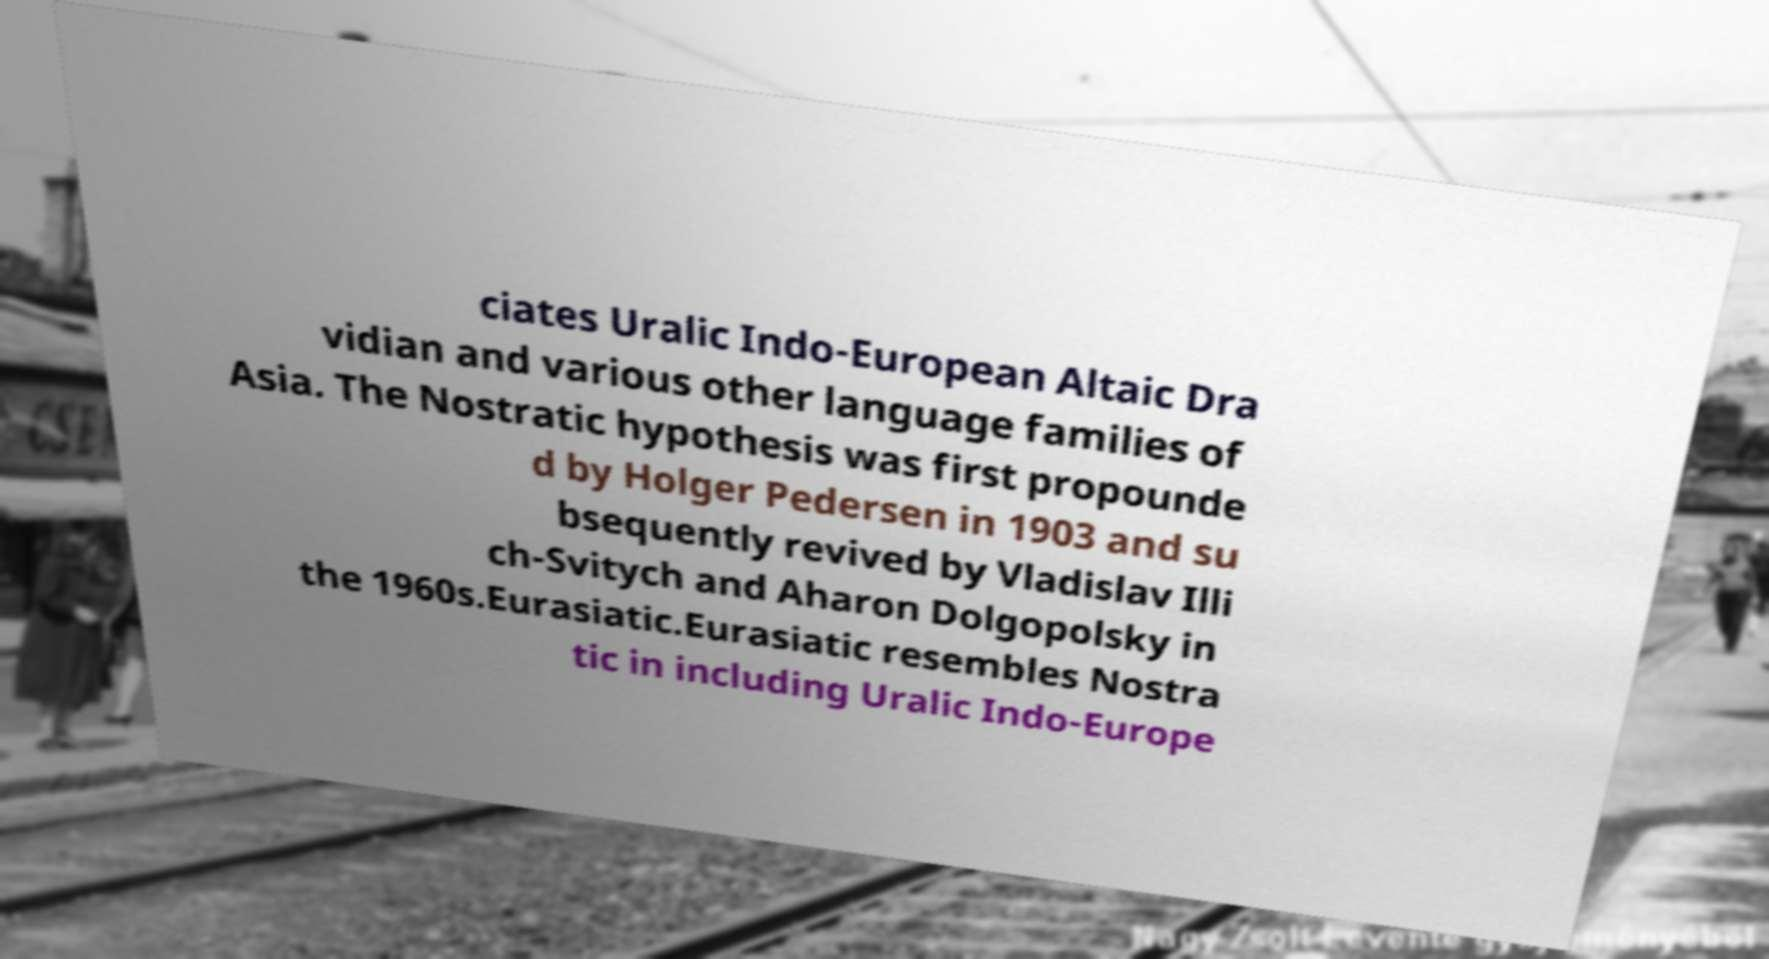There's text embedded in this image that I need extracted. Can you transcribe it verbatim? ciates Uralic Indo-European Altaic Dra vidian and various other language families of Asia. The Nostratic hypothesis was first propounde d by Holger Pedersen in 1903 and su bsequently revived by Vladislav Illi ch-Svitych and Aharon Dolgopolsky in the 1960s.Eurasiatic.Eurasiatic resembles Nostra tic in including Uralic Indo-Europe 